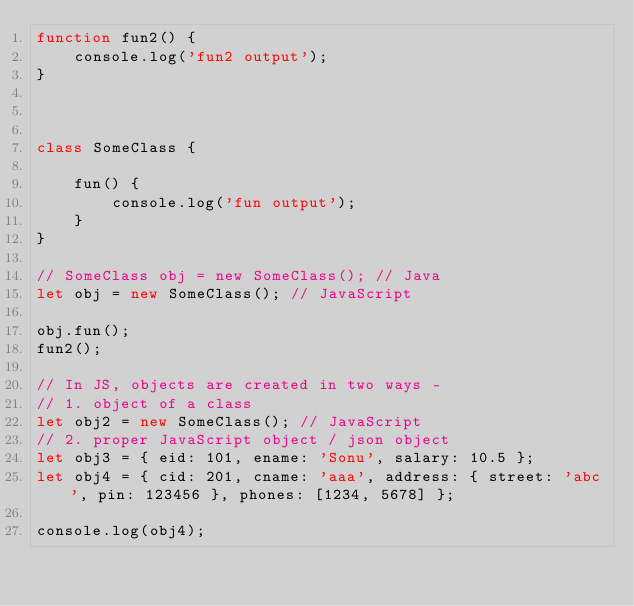<code> <loc_0><loc_0><loc_500><loc_500><_JavaScript_>function fun2() {
    console.log('fun2 output');
}



class SomeClass {

    fun() {
        console.log('fun output');
    }
}

// SomeClass obj = new SomeClass(); // Java 
let obj = new SomeClass(); // JavaScript 

obj.fun();
fun2();

// In JS, objects are created in two ways - 
// 1. object of a class 
let obj2 = new SomeClass(); // JavaScript 
// 2. proper JavaScript object / json object  
let obj3 = { eid: 101, ename: 'Sonu', salary: 10.5 };
let obj4 = { cid: 201, cname: 'aaa', address: { street: 'abc', pin: 123456 }, phones: [1234, 5678] };

console.log(obj4);</code> 